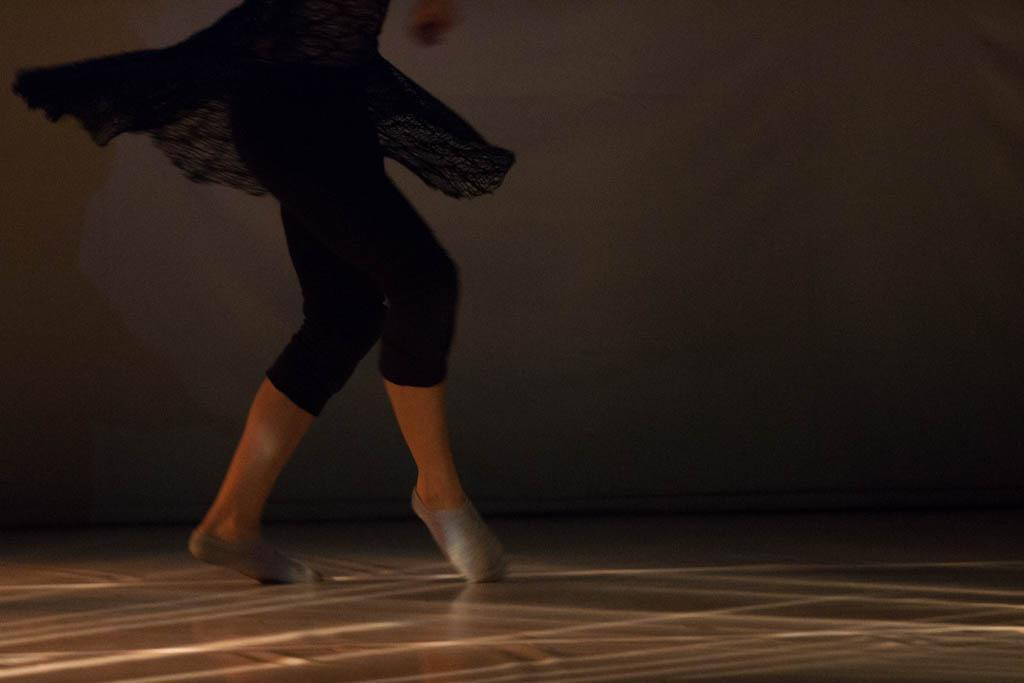Who is present in the image? There is a woman in the image. What part of the woman's body can be seen? The woman's legs are visible in the image. What is the woman wearing on her legs? The woman is wearing black trousers. What is the woman doing in the image? The woman is dancing on the floor. What can be seen behind the woman? There is a wall in the background of the image. How would you describe the lighting in the image? The background of the image is dark. What type of feast is being prepared in the image? There is no mention of a feast or any food preparation in the image; it features a woman dancing on the floor. Can you see any icicles hanging from the wall in the image? There are no icicles present in the image; the background is dark, but no specific details about the wall are mentioned. 